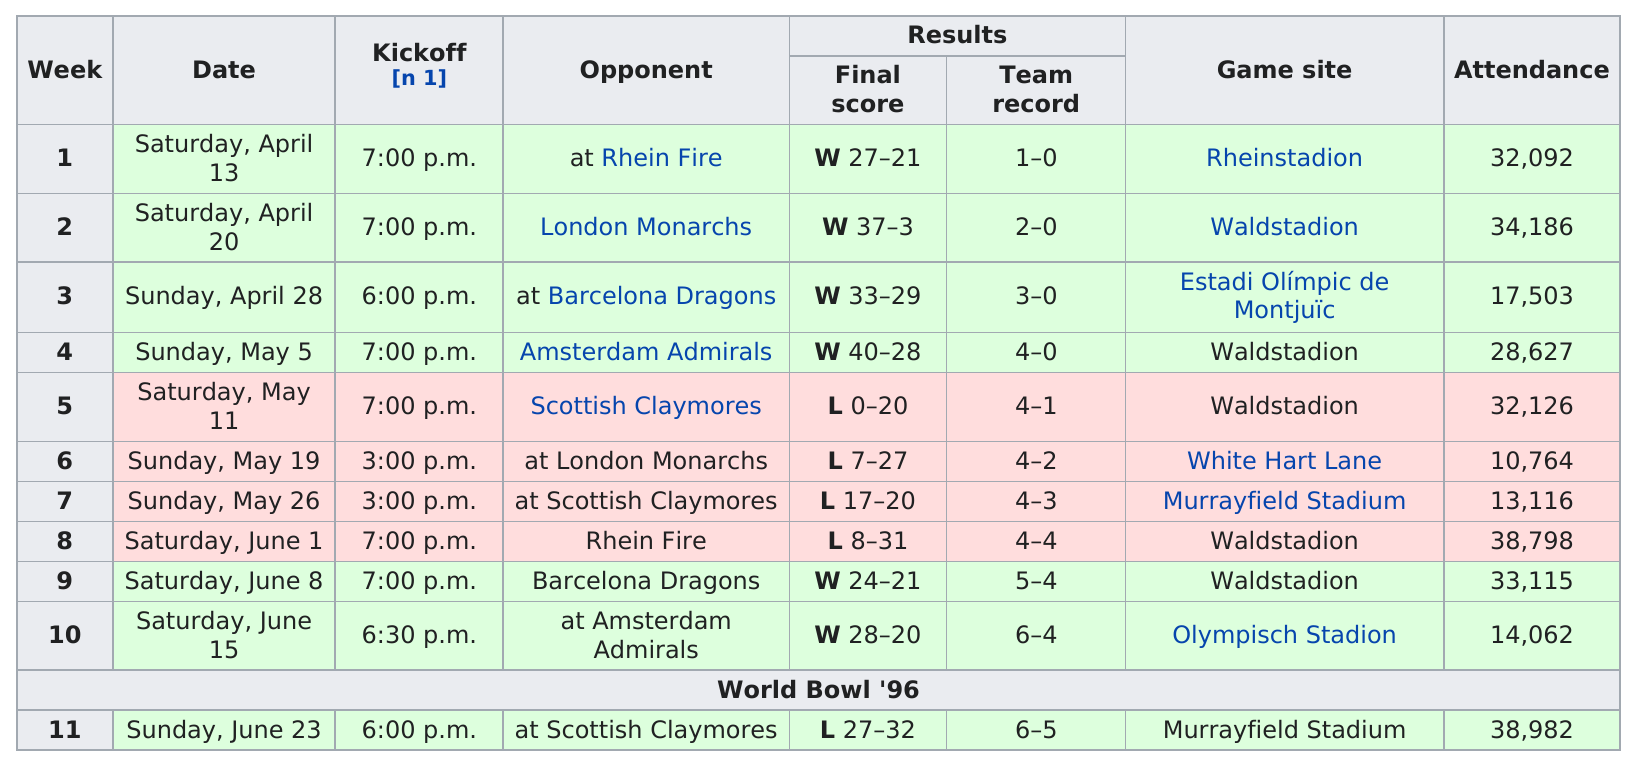Indicate a few pertinent items in this graphic. The attendance was significantly lower in the April 13th game compared to the May 11th game. A total of 5 games were played at the Waldstadion. With a final record of 6-5, the team can confidently look back on a successful season. The total amount of attendance between the first and second weeks is 66,278. After an epic matchup against the formidable dragons on June 8, our team triumphed with a resounding victory. Prior to this triumph, we had vanquished the Amsterdam Admirals, solidifying our position as the undisputed champions of the field. 